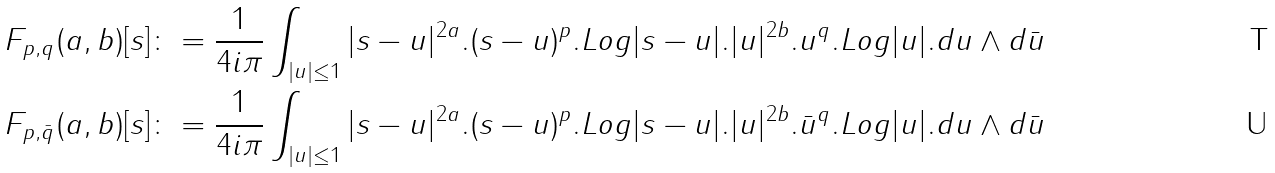<formula> <loc_0><loc_0><loc_500><loc_500>& F _ { p , q } ( a , b ) [ s ] \colon = \frac { 1 } { 4 i \pi } \int _ { | u | \leq 1 } | s - u | ^ { 2 a } . ( s - u ) ^ { p } . L o g | s - u | . | u | ^ { 2 b } . u ^ { q } . L o g | u | . d u \wedge d \bar { u } \\ & F _ { p , \bar { q } } ( a , b ) [ s ] \colon = \frac { 1 } { 4 i \pi } \int _ { | u | \leq 1 } | s - u | ^ { 2 a } . ( s - u ) ^ { p } . L o g | s - u | . | u | ^ { 2 b } . \bar { u } ^ { q } . L o g | u | . d u \wedge d \bar { u }</formula> 